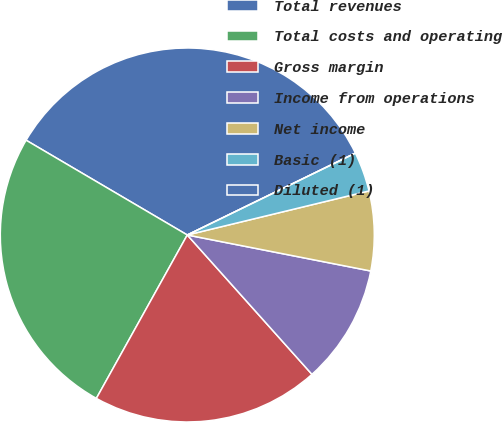Convert chart. <chart><loc_0><loc_0><loc_500><loc_500><pie_chart><fcel>Total revenues<fcel>Total costs and operating<fcel>Gross margin<fcel>Income from operations<fcel>Net income<fcel>Basic (1)<fcel>Diluted (1)<nl><fcel>34.33%<fcel>25.38%<fcel>19.7%<fcel>10.3%<fcel>6.87%<fcel>3.43%<fcel>0.0%<nl></chart> 